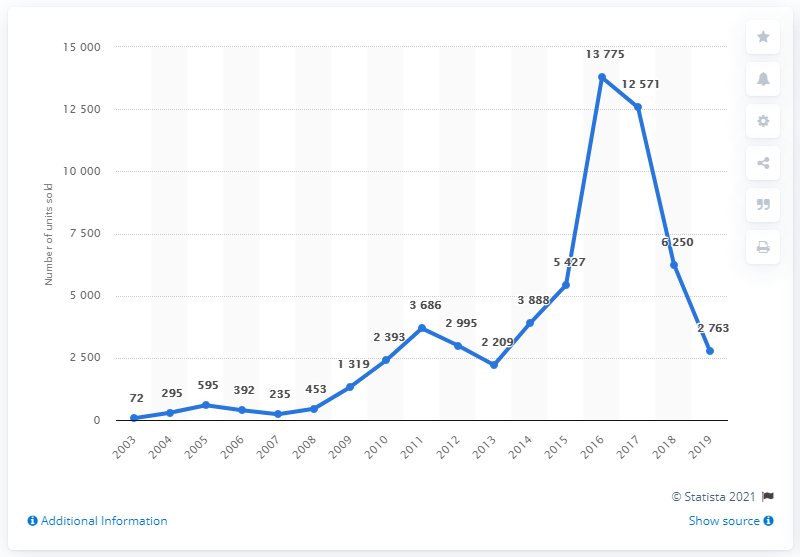Draw attention to some important aspects in this diagram. The average over the last 4 years is 8839.75. Car sales peaked in 2016. 